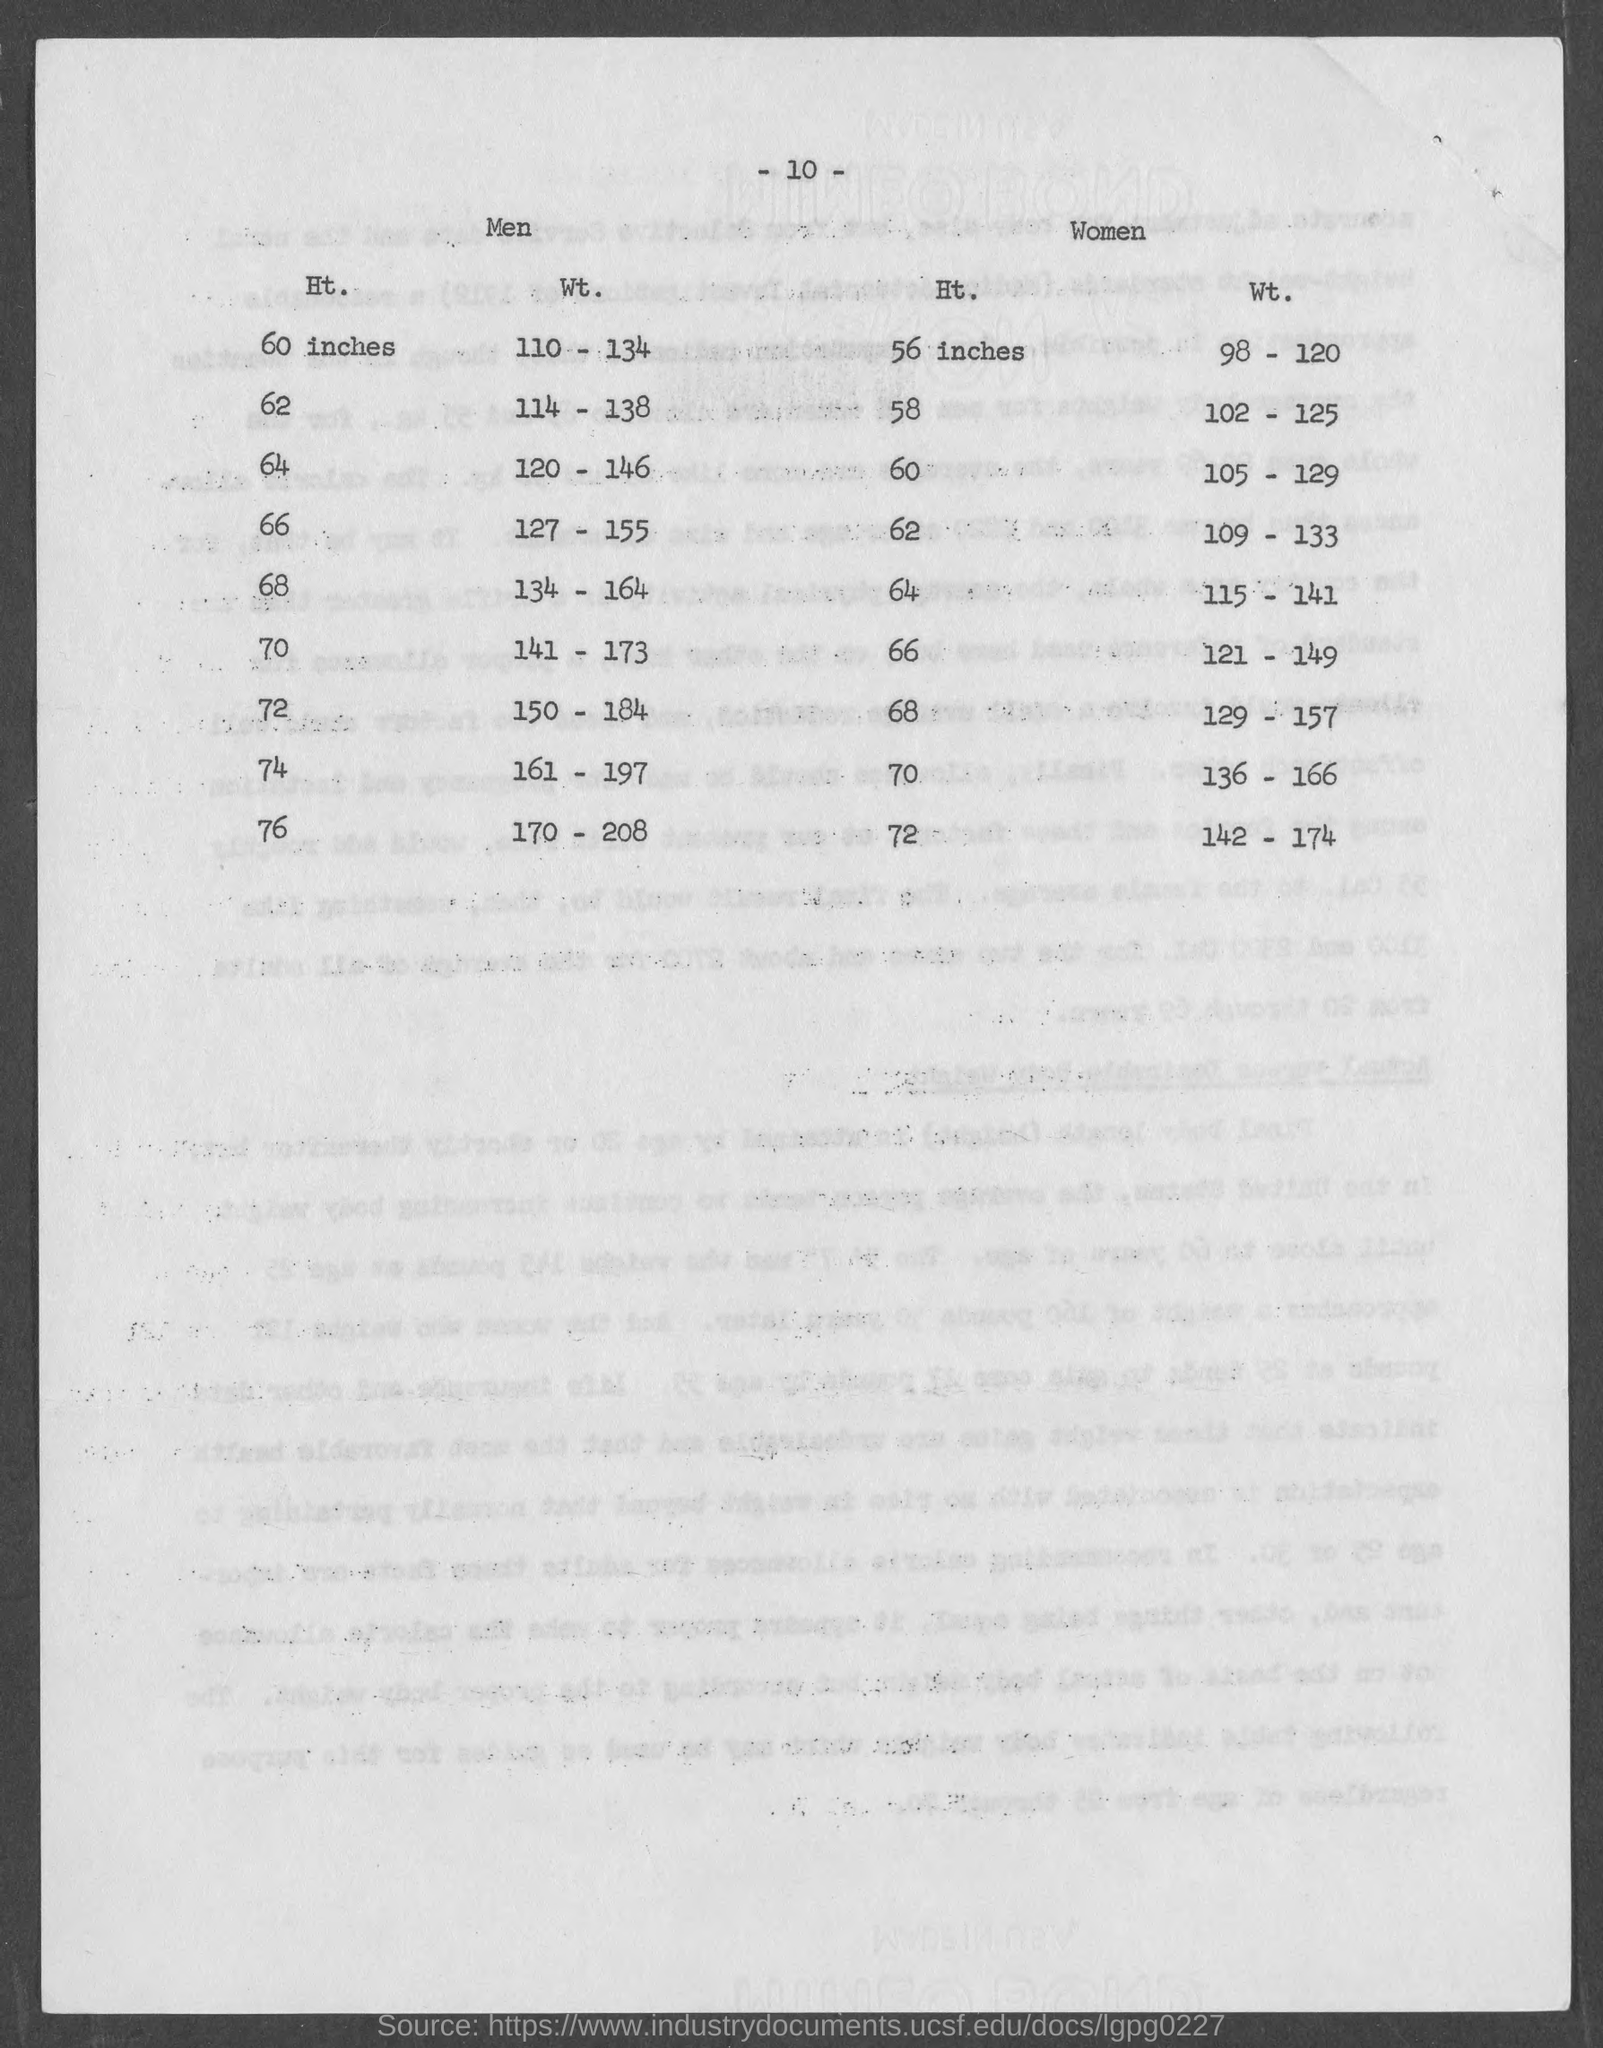What is the page number at top of the page?
Your answer should be compact. -10-. What must be the wt. for ht. 68 inches in men?
Your answer should be very brief. 134 - 164. What must be the wt. for ht. 70 inches in men ?
Provide a succinct answer. 141 - 173. What must be the wt. for ht. 74 inches in men ?
Provide a short and direct response. 161 - 197. What must be the wt. for ht. 76 inches in men ?
Provide a succinct answer. 170 - 208. 